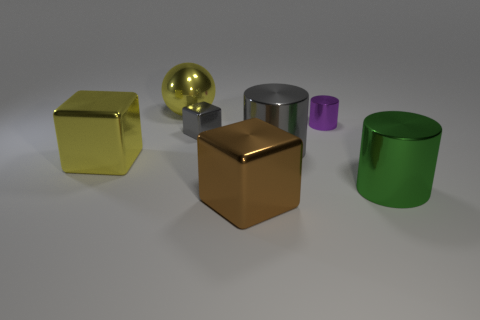Subtract all purple cubes. Subtract all red spheres. How many cubes are left? 3 Add 2 green metal cylinders. How many objects exist? 9 Subtract all cylinders. How many objects are left? 4 Subtract 0 green balls. How many objects are left? 7 Subtract all cyan metallic balls. Subtract all shiny balls. How many objects are left? 6 Add 7 large balls. How many large balls are left? 8 Add 3 metal objects. How many metal objects exist? 10 